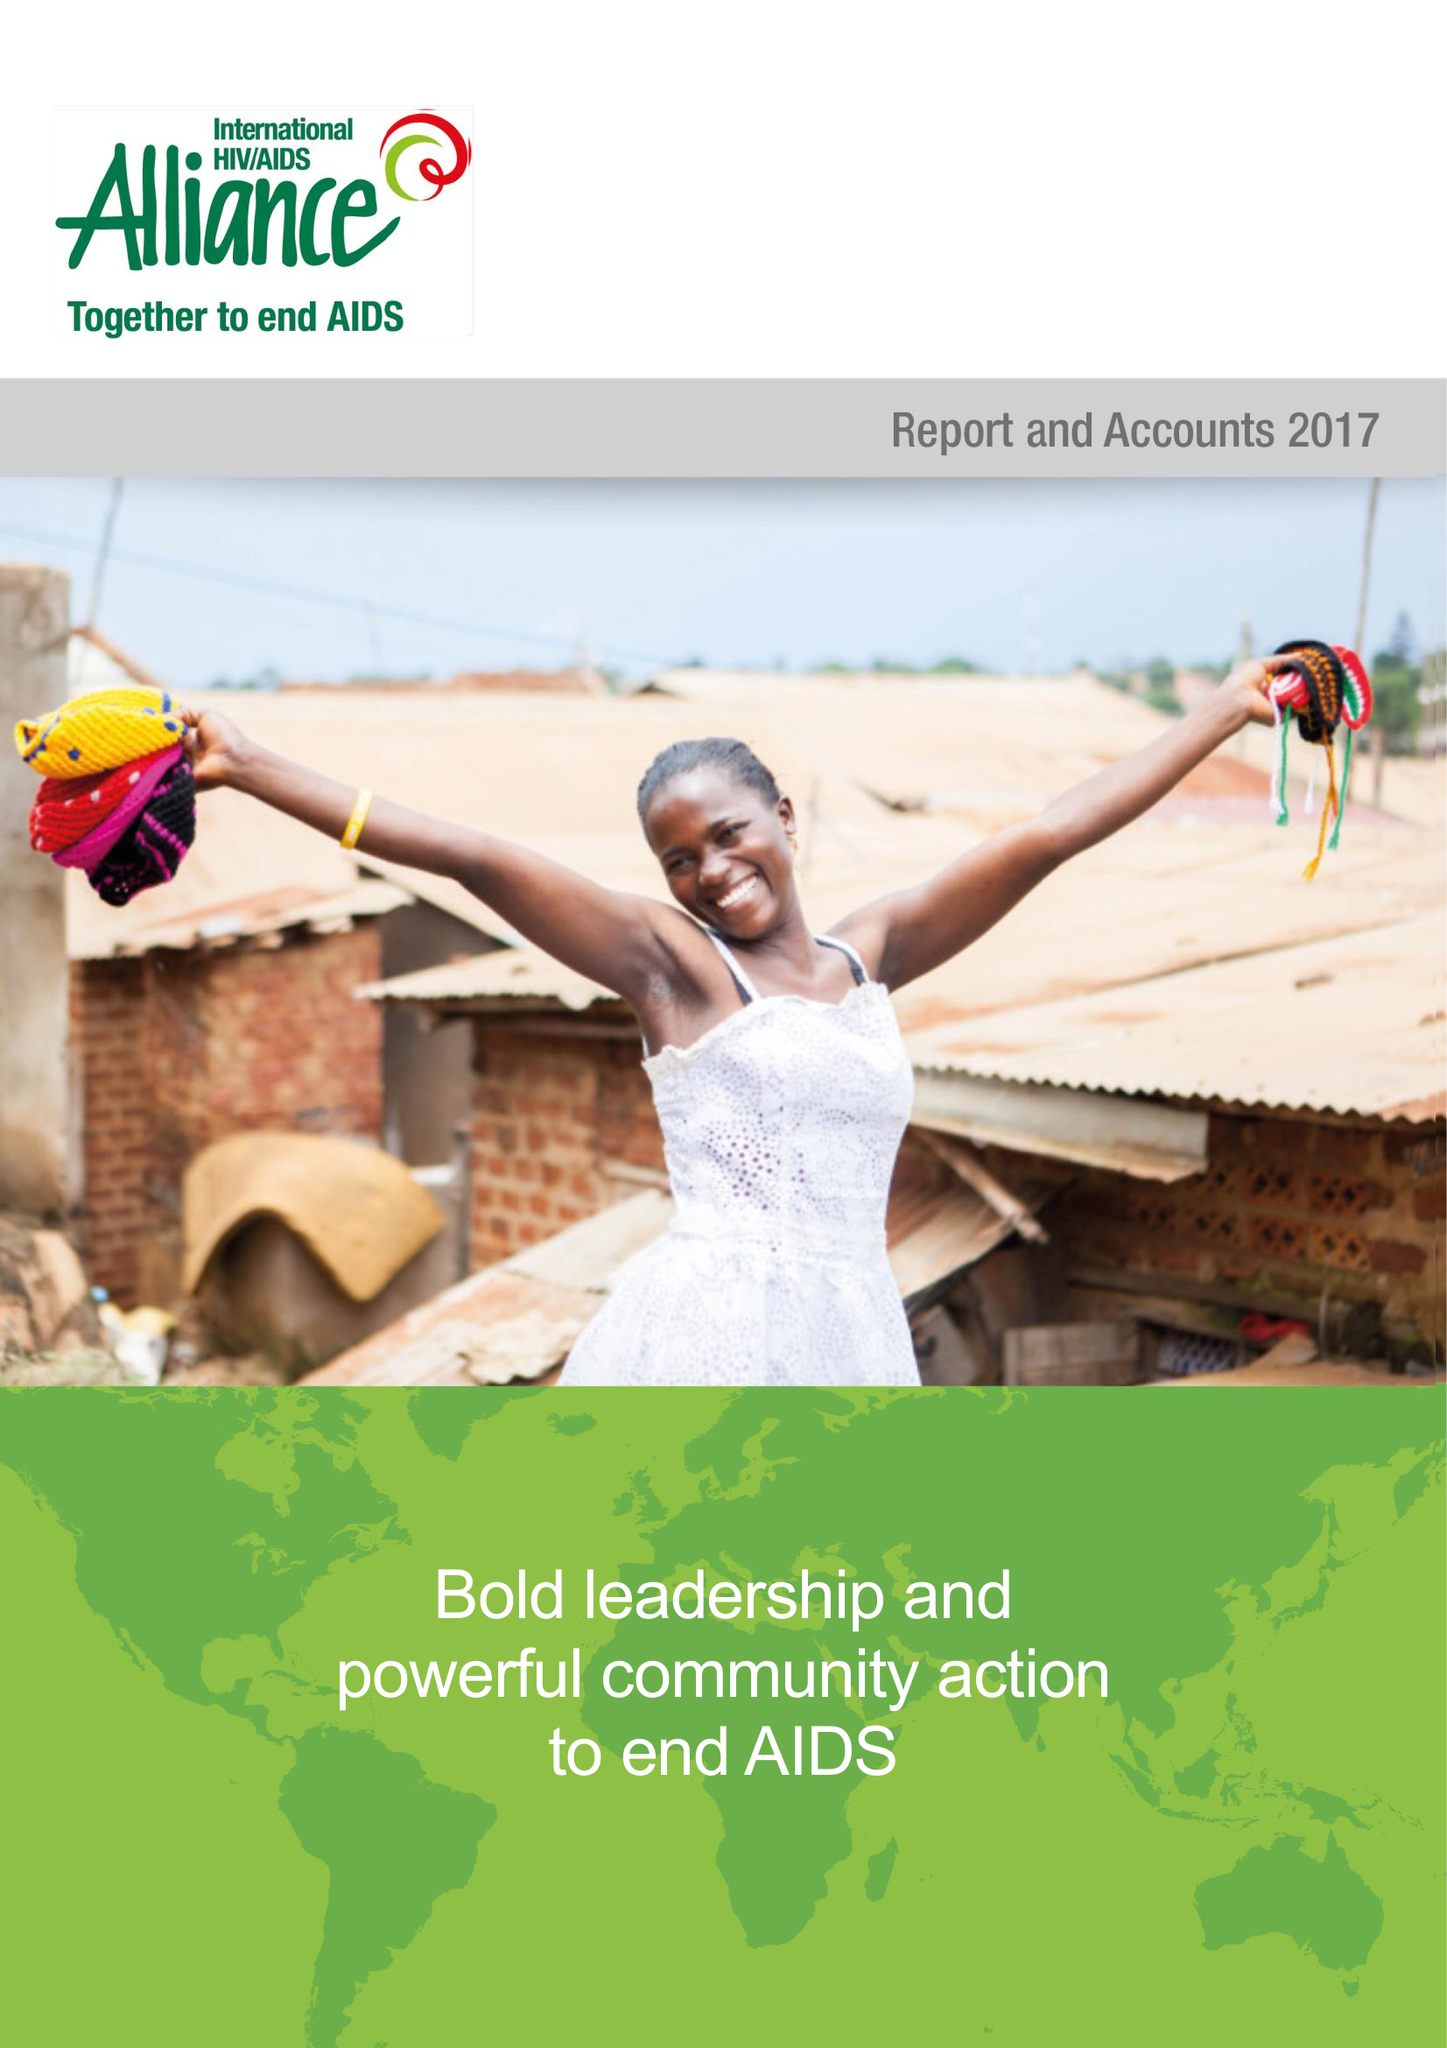What is the value for the address__post_town?
Answer the question using a single word or phrase. HOVE 